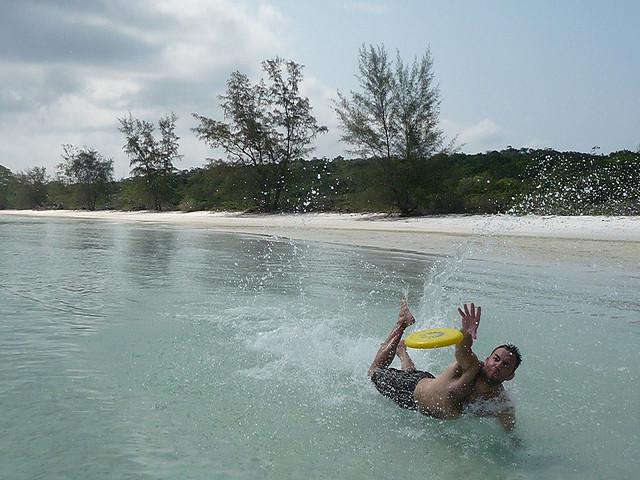What color is the frisbee?
Give a very brief answer. Yellow. What is the color of the water?
Give a very brief answer. Blue. Is the man trying to catch the frisbee while swimming?
Short answer required. Yes. What is this man doing?
Answer briefly. Frisbee. 